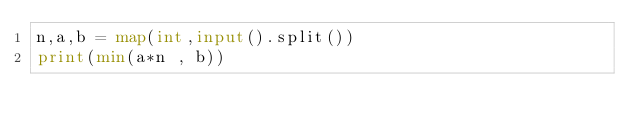Convert code to text. <code><loc_0><loc_0><loc_500><loc_500><_Python_>n,a,b = map(int,input().split())
print(min(a*n , b))</code> 